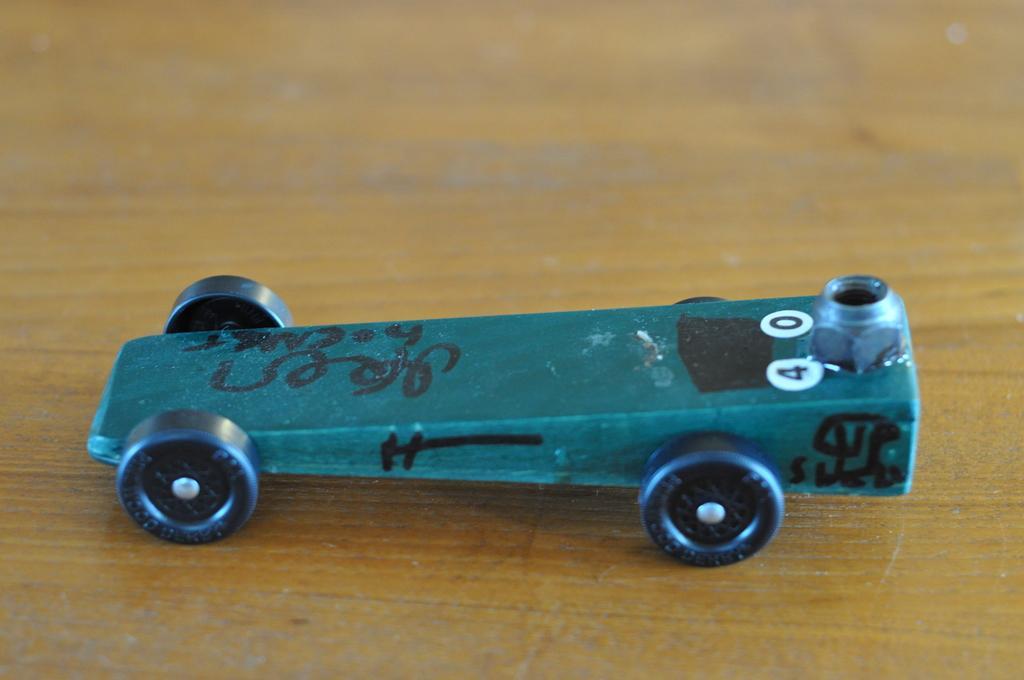How would you summarize this image in a sentence or two? Here we can see a toy on a wooden platform. 